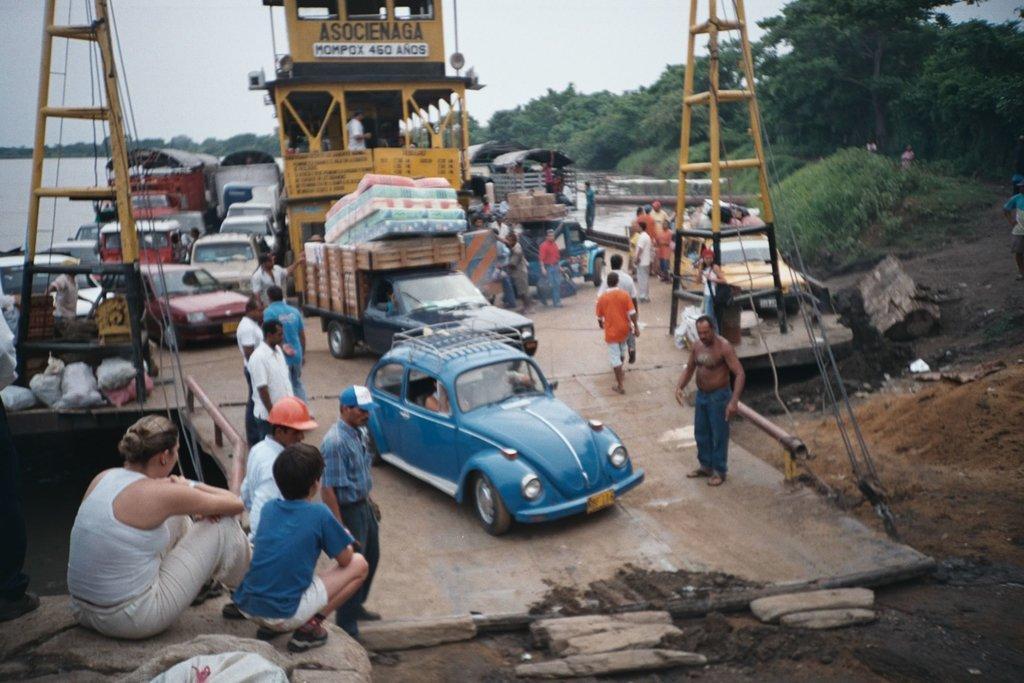Could you give a brief overview of what you see in this image? In this image we can see there are few vehicles and few people are on the road. On the left side of the image there is a river. In the background there are trees and a sky. 